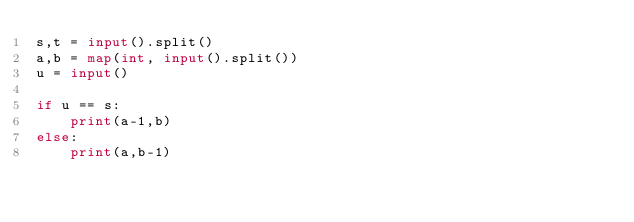<code> <loc_0><loc_0><loc_500><loc_500><_Python_>s,t = input().split()
a,b = map(int, input().split())
u = input()

if u == s:
    print(a-1,b)
else:
    print(a,b-1)</code> 